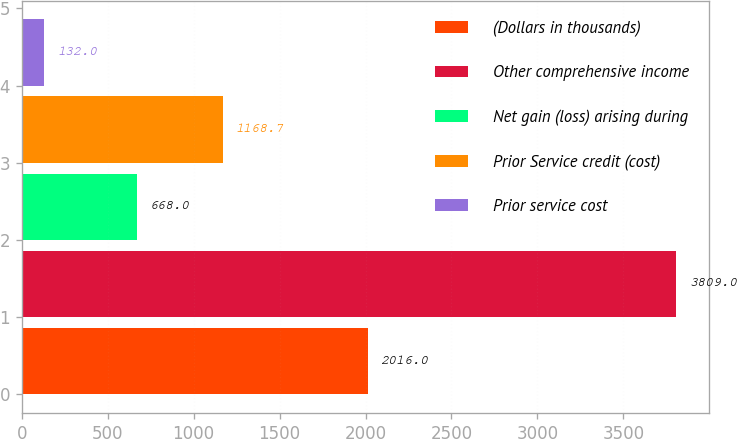Convert chart. <chart><loc_0><loc_0><loc_500><loc_500><bar_chart><fcel>(Dollars in thousands)<fcel>Other comprehensive income<fcel>Net gain (loss) arising during<fcel>Prior Service credit (cost)<fcel>Prior service cost<nl><fcel>2016<fcel>3809<fcel>668<fcel>1168.7<fcel>132<nl></chart> 